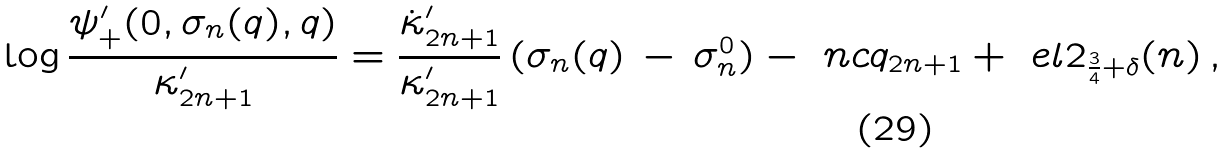<formula> <loc_0><loc_0><loc_500><loc_500>\log \frac { \psi ^ { \prime } _ { + } ( 0 , \sigma _ { n } ( q ) , q ) } { \kappa ^ { \prime } _ { 2 n + 1 } } = \frac { \dot { \kappa } ^ { \prime } _ { 2 n + 1 } } { \kappa ^ { \prime } _ { 2 n + 1 } } \, ( \sigma _ { n } ( q ) \, - \, \sigma _ { n } ^ { 0 } ) - { \ n c q _ { 2 n + 1 } } + \ e l 2 _ { \frac { 3 } { 4 } + \delta } ( n ) \, ,</formula> 